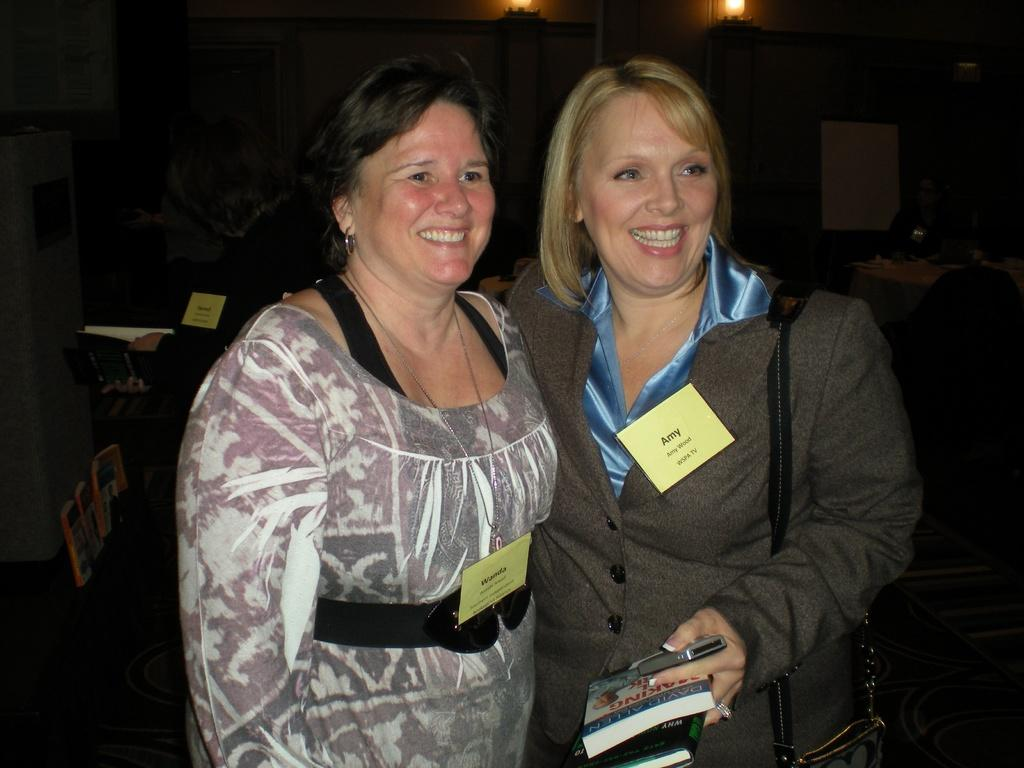What are the people in the image wearing? The persons in the image are wearing clothes. Can you describe the person on the right side of the image? The person on the right side of the image is holding a phone and a book. What can be seen at the top of the image? There are lights at the top of the image. What type of berry is being used as a system to organize the books in the image? There is no berry or system for organizing books present in the image. 